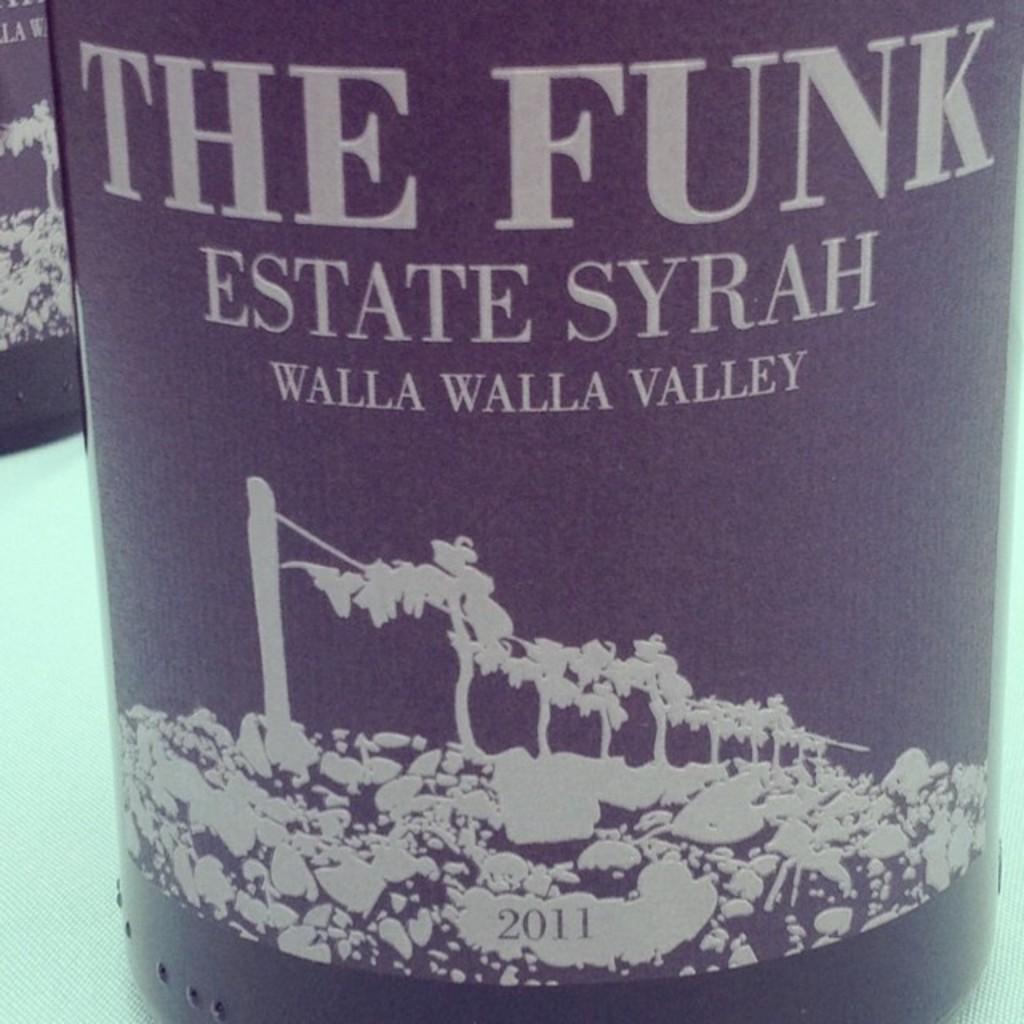What word comes after estate?
Your response must be concise. Syrah. What are the two words printed in the largest font?
Your response must be concise. The funk. 